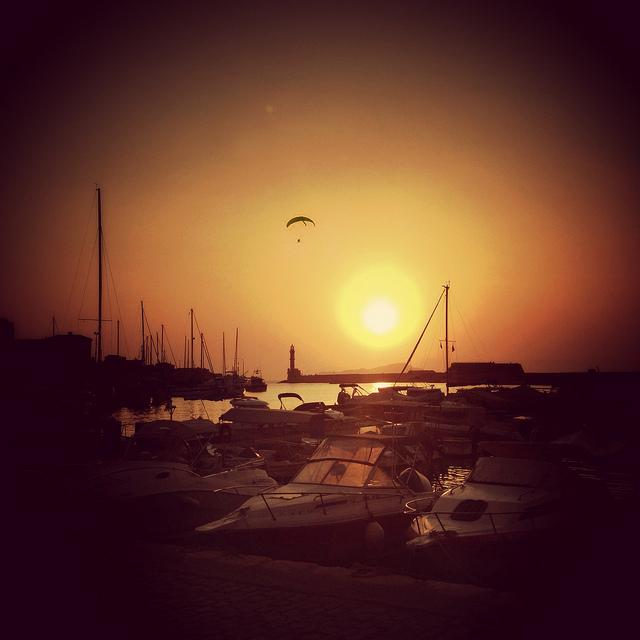This scene is likely to appear where? harbor 